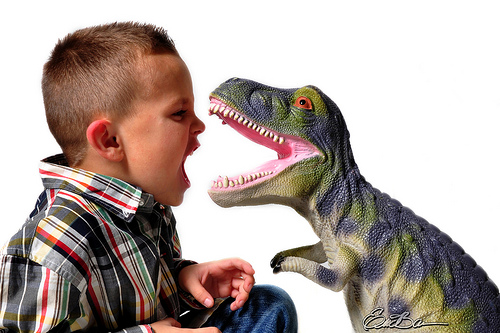<image>
Is the dino behind the boy? No. The dino is not behind the boy. From this viewpoint, the dino appears to be positioned elsewhere in the scene. 